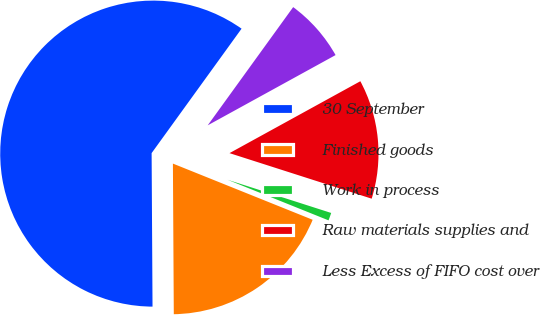<chart> <loc_0><loc_0><loc_500><loc_500><pie_chart><fcel>30 September<fcel>Finished goods<fcel>Work in process<fcel>Raw materials supplies and<fcel>Less Excess of FIFO cost over<nl><fcel>60.05%<fcel>18.82%<fcel>1.15%<fcel>12.93%<fcel>7.04%<nl></chart> 